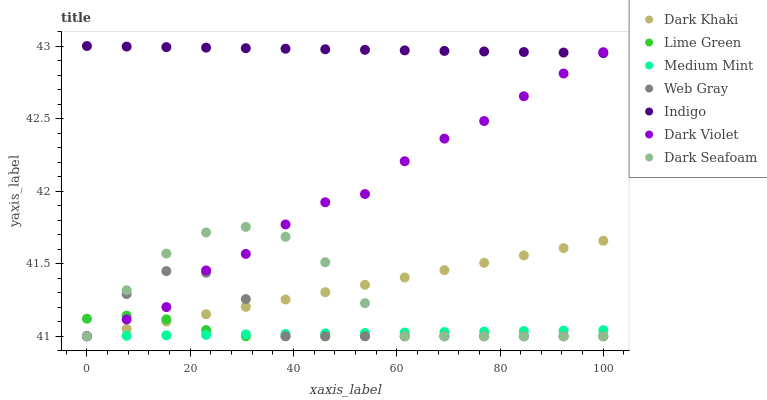Does Medium Mint have the minimum area under the curve?
Answer yes or no. Yes. Does Indigo have the maximum area under the curve?
Answer yes or no. Yes. Does Web Gray have the minimum area under the curve?
Answer yes or no. No. Does Web Gray have the maximum area under the curve?
Answer yes or no. No. Is Dark Khaki the smoothest?
Answer yes or no. Yes. Is Dark Violet the roughest?
Answer yes or no. Yes. Is Web Gray the smoothest?
Answer yes or no. No. Is Web Gray the roughest?
Answer yes or no. No. Does Medium Mint have the lowest value?
Answer yes or no. Yes. Does Indigo have the lowest value?
Answer yes or no. No. Does Indigo have the highest value?
Answer yes or no. Yes. Does Web Gray have the highest value?
Answer yes or no. No. Is Medium Mint less than Indigo?
Answer yes or no. Yes. Is Indigo greater than Web Gray?
Answer yes or no. Yes. Does Medium Mint intersect Dark Khaki?
Answer yes or no. Yes. Is Medium Mint less than Dark Khaki?
Answer yes or no. No. Is Medium Mint greater than Dark Khaki?
Answer yes or no. No. Does Medium Mint intersect Indigo?
Answer yes or no. No. 